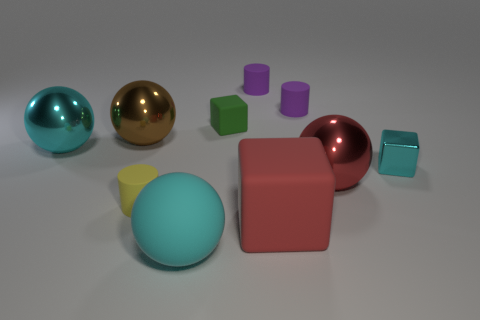What color is the large thing that is the same shape as the tiny shiny object?
Offer a terse response. Red. Is there anything else that has the same shape as the brown object?
Give a very brief answer. Yes. Is the color of the small thing that is in front of the cyan shiny block the same as the big rubber block?
Offer a very short reply. No. The cyan metal thing that is the same shape as the tiny green matte object is what size?
Make the answer very short. Small. What number of large cyan spheres are the same material as the green object?
Offer a very short reply. 1. There is a tiny block in front of the large cyan thing that is behind the tiny metal block; is there a tiny thing that is in front of it?
Keep it short and to the point. Yes. What shape is the green thing?
Offer a very short reply. Cube. Is the cyan sphere that is on the left side of the brown ball made of the same material as the sphere that is right of the cyan matte sphere?
Offer a terse response. Yes. How many rubber objects have the same color as the metal cube?
Make the answer very short. 1. There is a tiny object that is both behind the large brown metallic sphere and right of the big matte cube; what shape is it?
Your answer should be compact. Cylinder. 